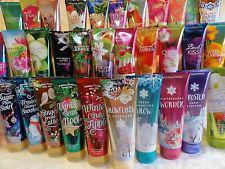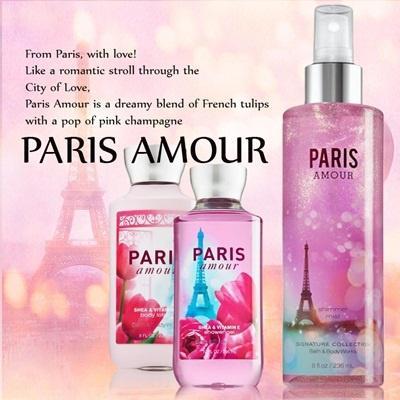The first image is the image on the left, the second image is the image on the right. Considering the images on both sides, is "One of the images has exactly three bottles." valid? Answer yes or no. Yes. The first image is the image on the left, the second image is the image on the right. Assess this claim about the two images: "There are exactly three products in one of the images.". Correct or not? Answer yes or no. Yes. 